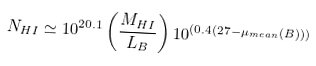<formula> <loc_0><loc_0><loc_500><loc_500>N _ { H I } \simeq 1 0 ^ { 2 0 . 1 } \left ( \frac { M _ { H I } } { L _ { B } } \right ) 1 0 ^ { \left ( 0 . 4 \left ( 2 7 - \mu _ { m e a n } ( B ) \right ) \right ) }</formula> 